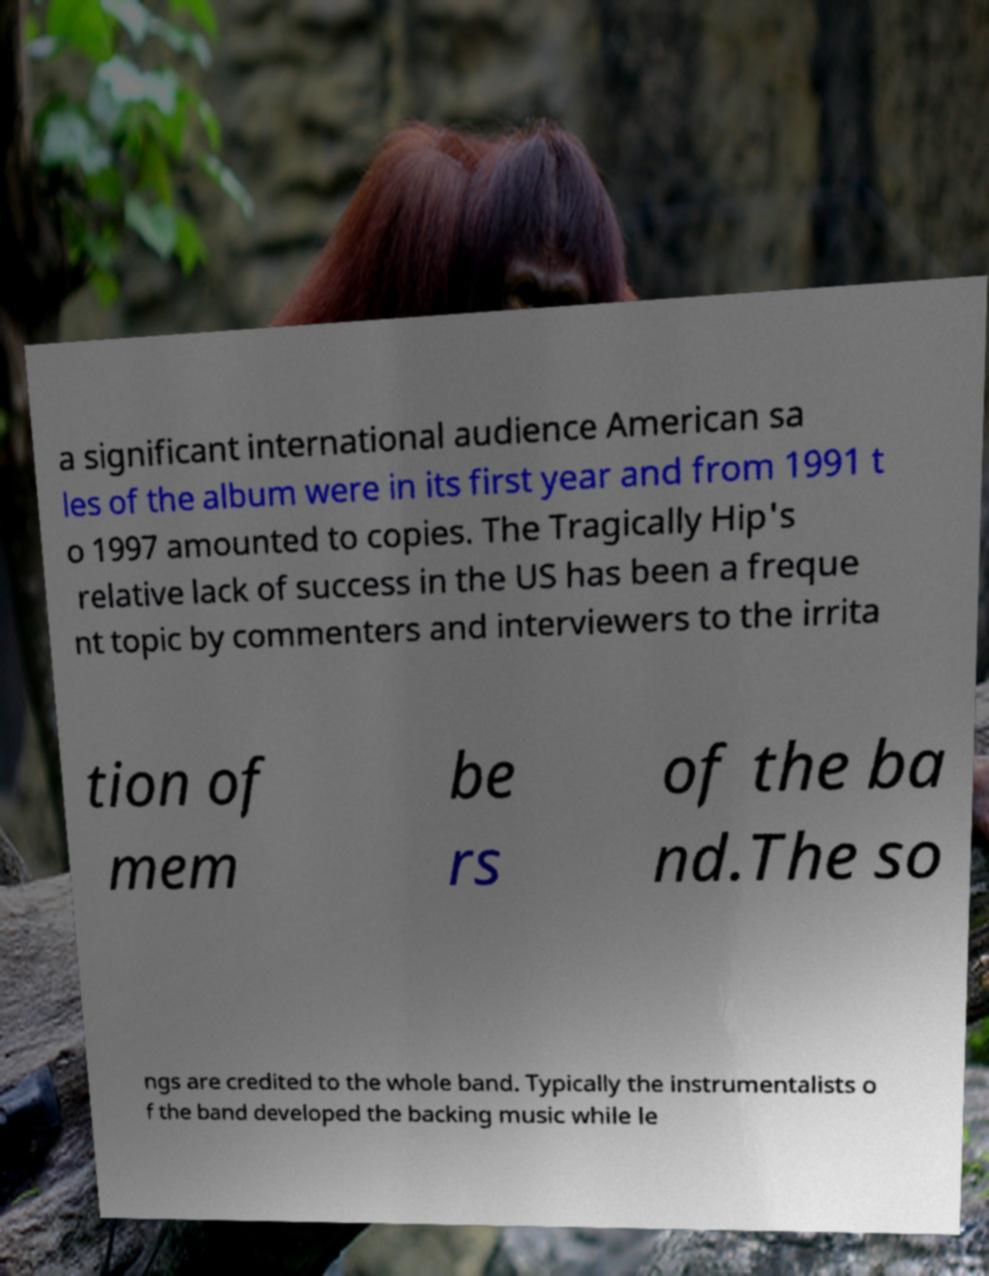Please identify and transcribe the text found in this image. a significant international audience American sa les of the album were in its first year and from 1991 t o 1997 amounted to copies. The Tragically Hip's relative lack of success in the US has been a freque nt topic by commenters and interviewers to the irrita tion of mem be rs of the ba nd.The so ngs are credited to the whole band. Typically the instrumentalists o f the band developed the backing music while le 